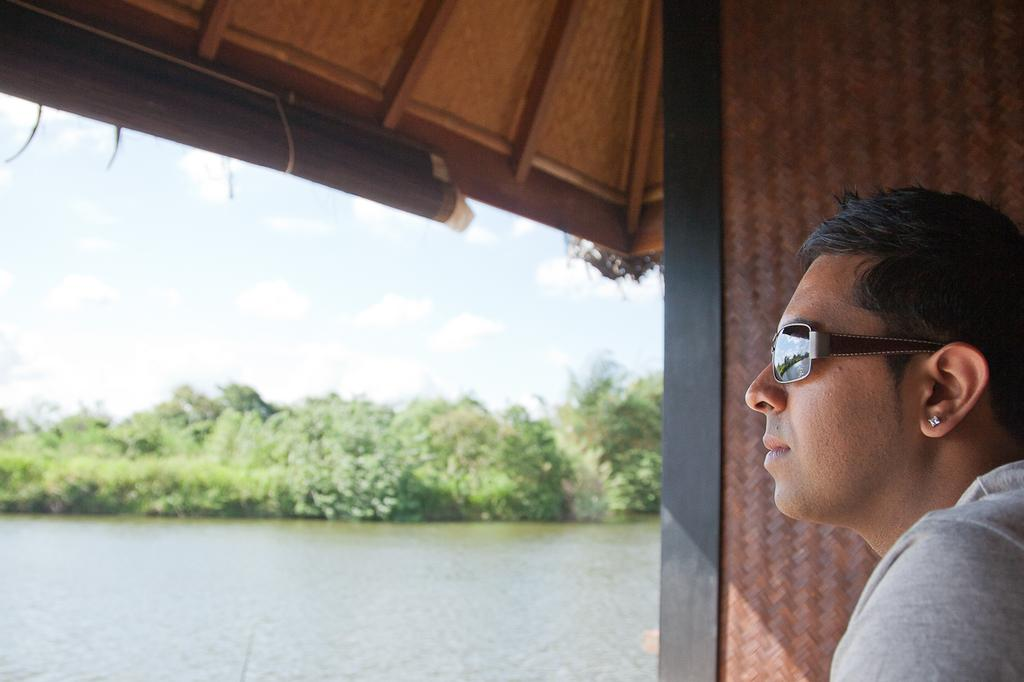What is present in the image? There is a person in the image. Can you describe the person's attire? The person is wearing an ash-colored dress. What can be seen in the background of the image? There are trees, water, and a brown wall visible in the background. What type of tin can be seen in the person's elbow in the image? There is no tin or any reference to an elbow in the image; it features a person wearing an ash-colored dress with a background of trees, water, and a brown wall. 